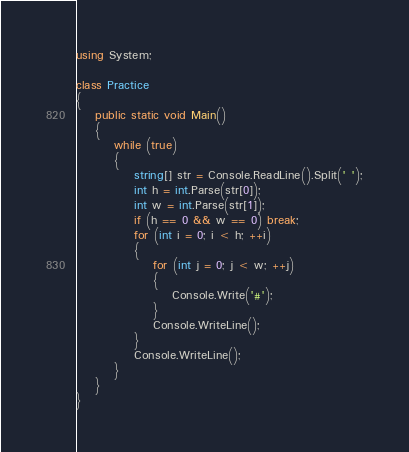Convert code to text. <code><loc_0><loc_0><loc_500><loc_500><_C#_>using System;

class Practice
{
    public static void Main()
    {
        while (true)
        {
            string[] str = Console.ReadLine().Split(' ');
            int h = int.Parse(str[0]);
            int w = int.Parse(str[1]);
            if (h == 0 && w == 0) break;
            for (int i = 0; i < h; ++i)
            {
                for (int j = 0; j < w; ++j)
                {
                    Console.Write('#');
                }
                Console.WriteLine();
            }
            Console.WriteLine();
        }
    }
}
</code> 